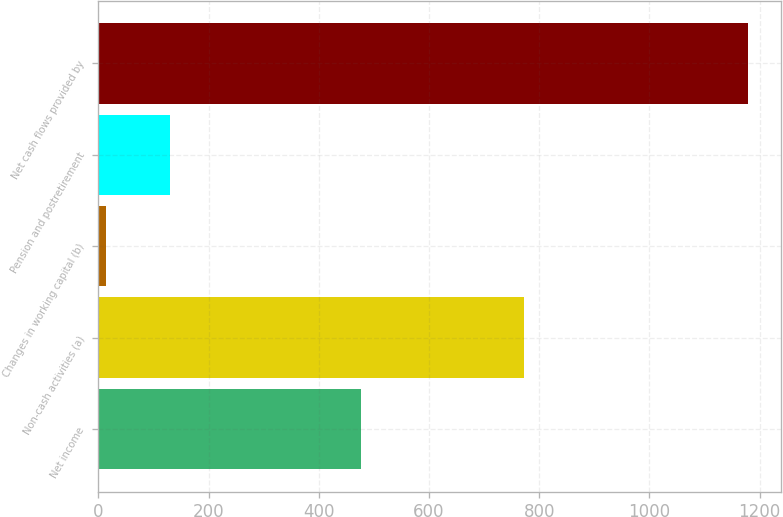Convert chart. <chart><loc_0><loc_0><loc_500><loc_500><bar_chart><fcel>Net income<fcel>Non-cash activities (a)<fcel>Changes in working capital (b)<fcel>Pension and postretirement<fcel>Net cash flows provided by<nl><fcel>476<fcel>773<fcel>13<fcel>129.6<fcel>1179<nl></chart> 